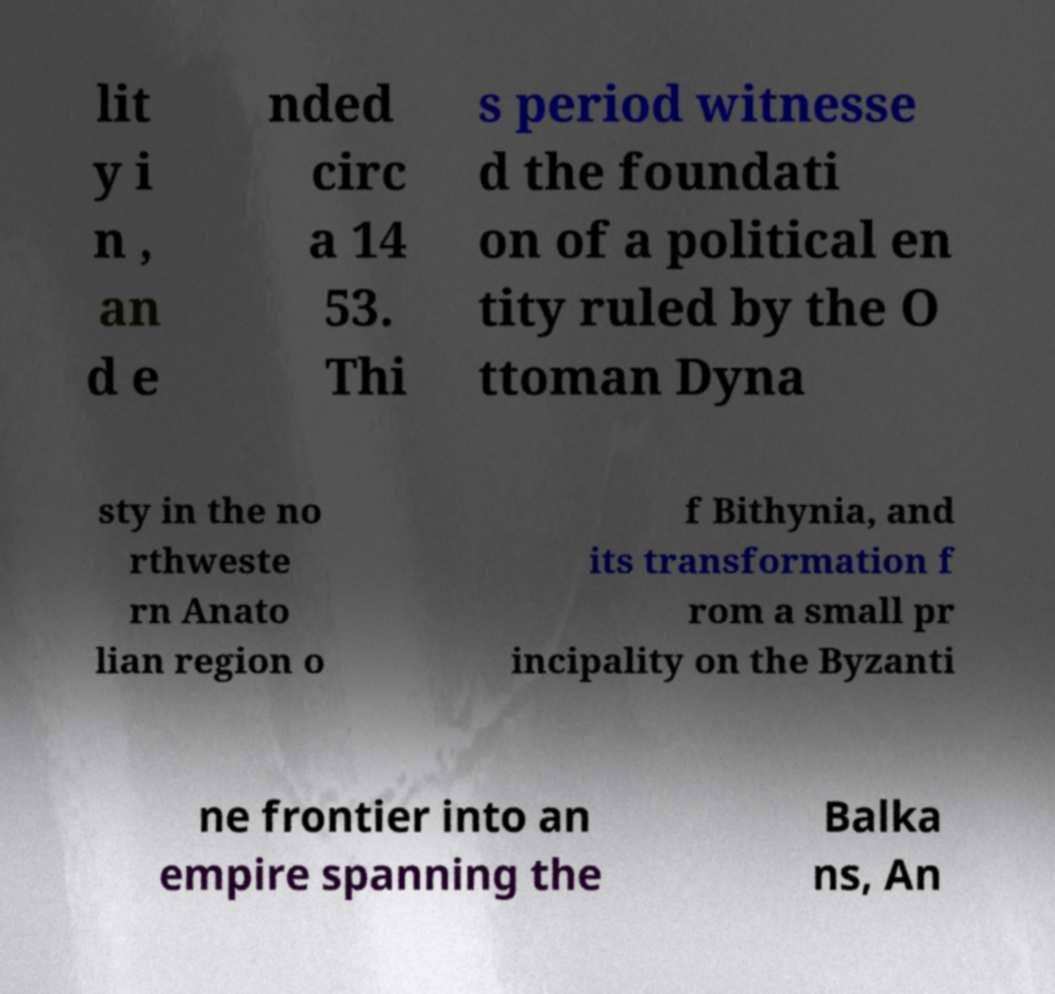Can you accurately transcribe the text from the provided image for me? lit y i n , an d e nded circ a 14 53. Thi s period witnesse d the foundati on of a political en tity ruled by the O ttoman Dyna sty in the no rthweste rn Anato lian region o f Bithynia, and its transformation f rom a small pr incipality on the Byzanti ne frontier into an empire spanning the Balka ns, An 